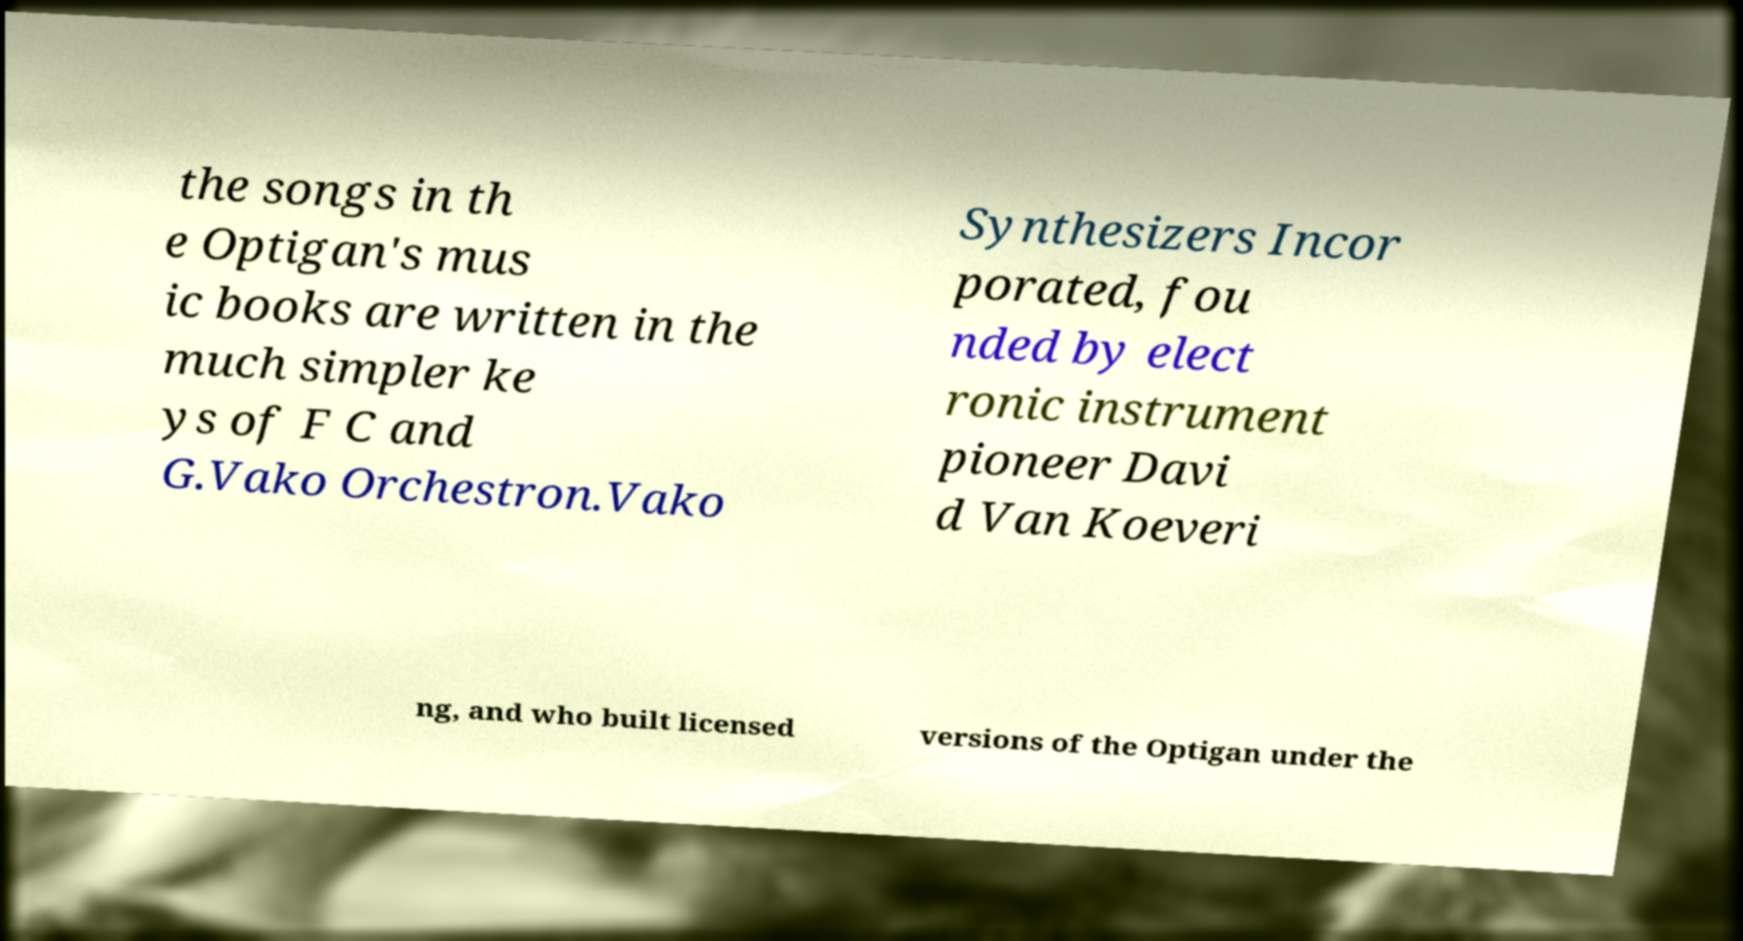Could you assist in decoding the text presented in this image and type it out clearly? the songs in th e Optigan's mus ic books are written in the much simpler ke ys of F C and G.Vako Orchestron.Vako Synthesizers Incor porated, fou nded by elect ronic instrument pioneer Davi d Van Koeveri ng, and who built licensed versions of the Optigan under the 